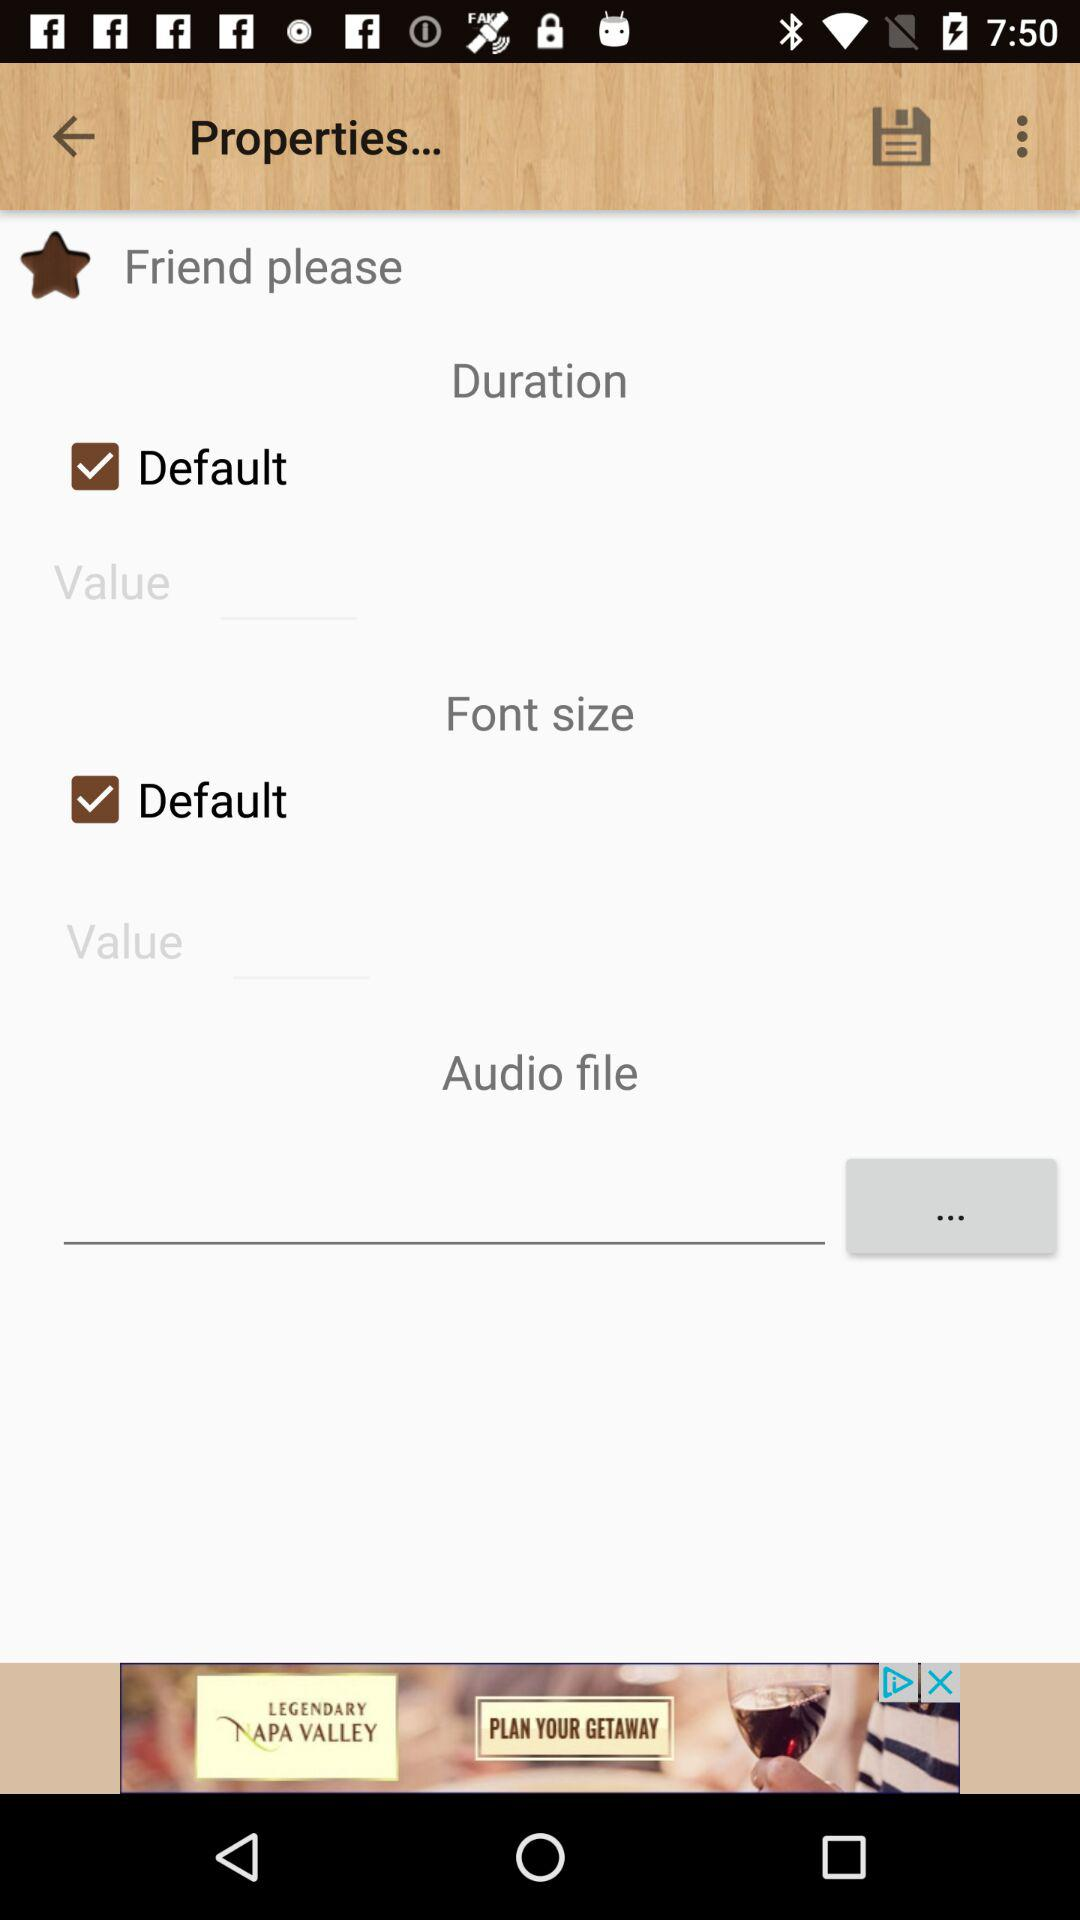What is the current status of the "Default" in font size? The current status is "on". 